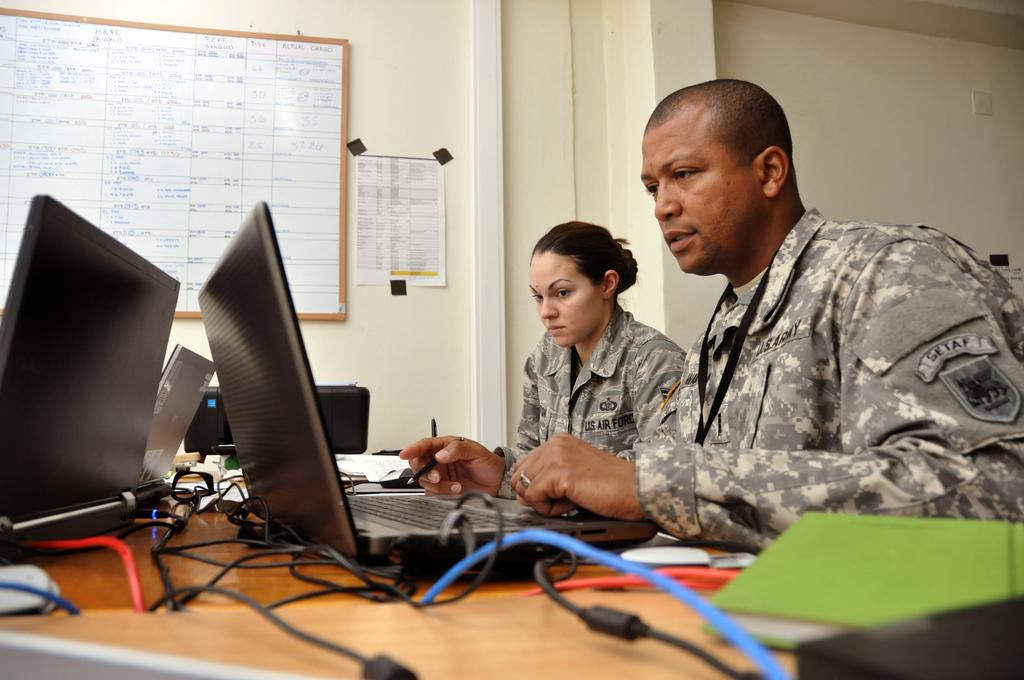Provide a one-sentence caption for the provided image. Two US Airforce personnel sitting at a desk looking at their laptop. 